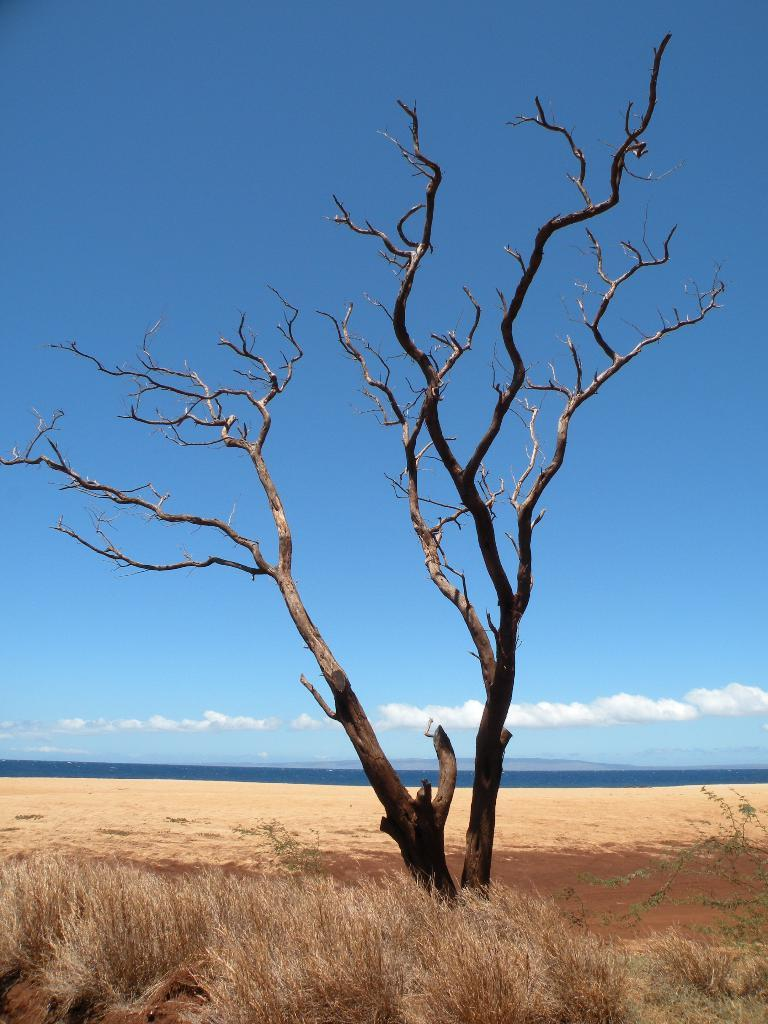What type of tree is in the image? There is a dried tree in the image. What other vegetation can be seen in the image? There is dried grass in the image. What colors are present in the sky in the image? The sky is blue and white in color. How many babies are playing with the parcels in the image? There are no babies or parcels present in the image. 